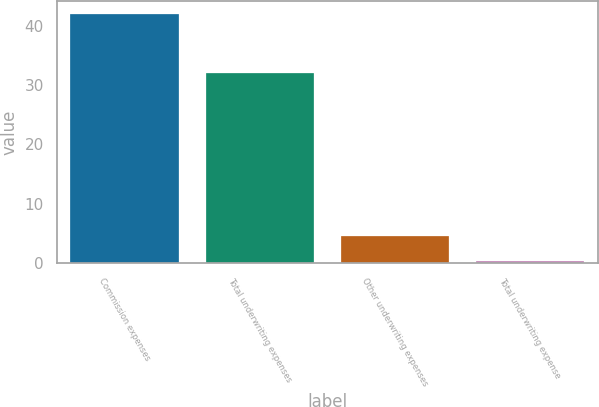<chart> <loc_0><loc_0><loc_500><loc_500><bar_chart><fcel>Commission expenses<fcel>Total underwriting expenses<fcel>Other underwriting expenses<fcel>Total underwriting expense<nl><fcel>42<fcel>32<fcel>4.47<fcel>0.3<nl></chart> 